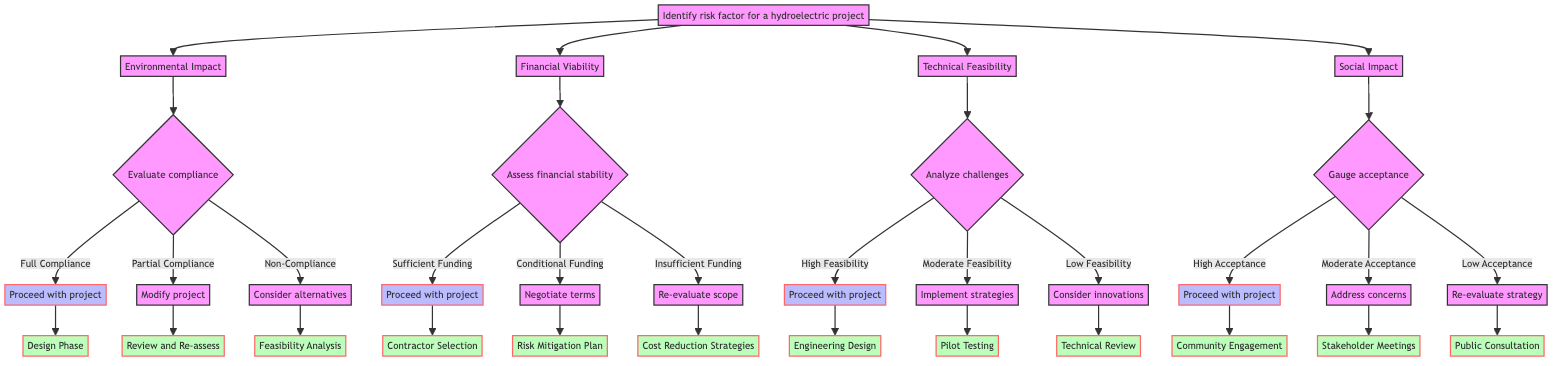What is the first question in the decision tree? The first question in the decision tree is found at the root node, which is "Identify risk factor for a hydroelectric project."
Answer: Identify risk factor for a hydroelectric project How many main risk factors are identified? There are four main risk factors identified in the decision tree: Environmental Impact, Financial Viability, Technical Feasibility, and Social Impact.
Answer: Four What action is taken if there is "Full Compliance" with environmental regulations? If there is "Full Compliance," the action taken is to "Proceed with project." This answer is found directly under the corresponding node for environmental impact compliance.
Answer: Proceed with project What happens if the financial assessment shows "Insufficient Funding"? If the financial assessment shows "Insufficient Funding," the recommended action is to "Re-evaluate project scope or financing." This is a clear outcome stated in the conditional branch of the financial viability assessment.
Answer: Re-evaluate project scope or financing What node follows "Moderate Feasibility" in the technical feasibility section? Following "Moderate Feasibility," the next step in the diagram is "Implement risk mitigation strategies," indicating a necessary action based on the level of feasibility assessed.
Answer: Implement risk mitigation strategies What is the recommended action if community acceptance is low? If community acceptance is low, the action is to "Re-evaluate the project's social strategy." This instructs the stakeholders to consider modifications or reassessments based on social impact factors outlined in the decision tree.
Answer: Re-evaluate the project's social strategy What does the diagram suggest if "Conditional Funding" is found? If "Conditional Funding" is found, the diagram suggests the action to "Negotiate financial terms," indicating that financial discussions are necessary before proceeding further.
Answer: Negotiate financial terms Which next step follows if the action is to "Proceed with project" after "High Acceptance"? After the action "Proceed with project" due to "High Acceptance," the next step indicated in the diagram is "Community Engagement." This suggests the project will move forward with a focus on community involvement.
Answer: Community Engagement 